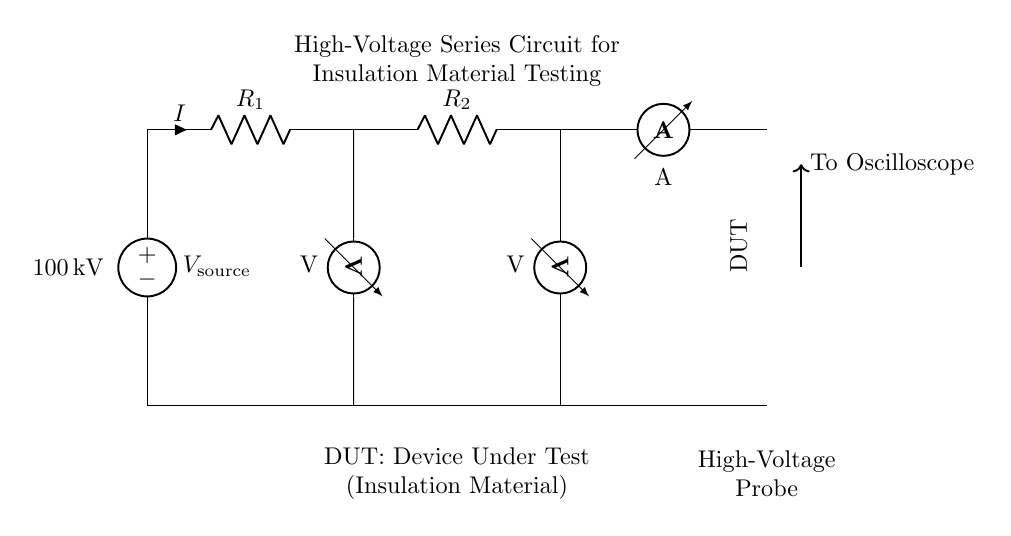What is the source voltage in this circuit? The source voltage, indicated by the voltage source label, is 100 kilovolts, which represents the electrical potential supplied to the circuit.
Answer: 100 kilovolt What type of circuit is shown in the diagram? The circuit diagram represents a series circuit, as all components including resistors and the device under test are connected one after another, leading to a single path for current flow.
Answer: Series circuit How many resistors are in this circuit? There are two resistors, labeled as R1 and R2, which are connected in a series arrangement with the device under test and the other components.
Answer: Two What does DUT stand for in this circuit? DUT stands for Device Under Test, which refers to the insulation material being evaluated in the circuit.
Answer: Device Under Test What is measured by the ammeter in this circuit? The ammeter measures the current flowing through the circuit, indicated by the 'I' symbol next to it, which represents the flow of electric charge.
Answer: Current Which component is connected to the oscilloscope? The high-voltage probe is connected to the oscilloscope, allowing for the measurement and analysis of voltage at the output of the device under test.
Answer: High-voltage probe What is the purpose of the voltmeters in this circuit? The voltmeters are used to measure the voltage across each of the two resistors, providing critical data for analyzing insulation performance based on the voltage drop across them.
Answer: Measure voltage 